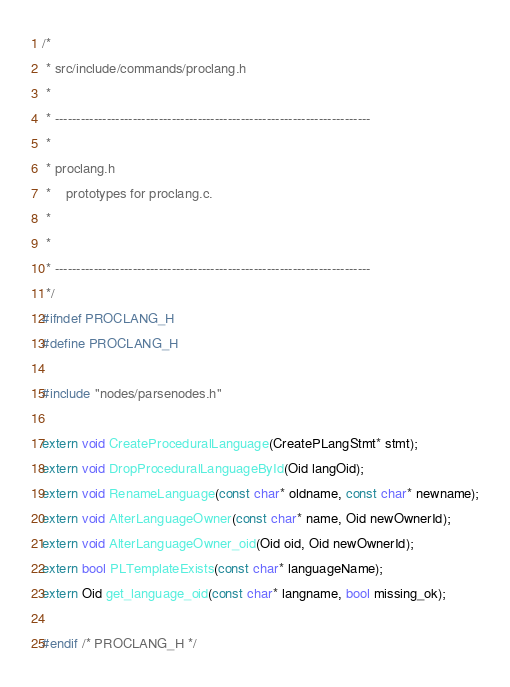<code> <loc_0><loc_0><loc_500><loc_500><_C_>/*
 * src/include/commands/proclang.h
 *
 * -------------------------------------------------------------------------
 *
 * proclang.h
 *	  prototypes for proclang.c.
 *
 *
 * -------------------------------------------------------------------------
 */
#ifndef PROCLANG_H
#define PROCLANG_H

#include "nodes/parsenodes.h"

extern void CreateProceduralLanguage(CreatePLangStmt* stmt);
extern void DropProceduralLanguageById(Oid langOid);
extern void RenameLanguage(const char* oldname, const char* newname);
extern void AlterLanguageOwner(const char* name, Oid newOwnerId);
extern void AlterLanguageOwner_oid(Oid oid, Oid newOwnerId);
extern bool PLTemplateExists(const char* languageName);
extern Oid get_language_oid(const char* langname, bool missing_ok);

#endif /* PROCLANG_H */
</code> 